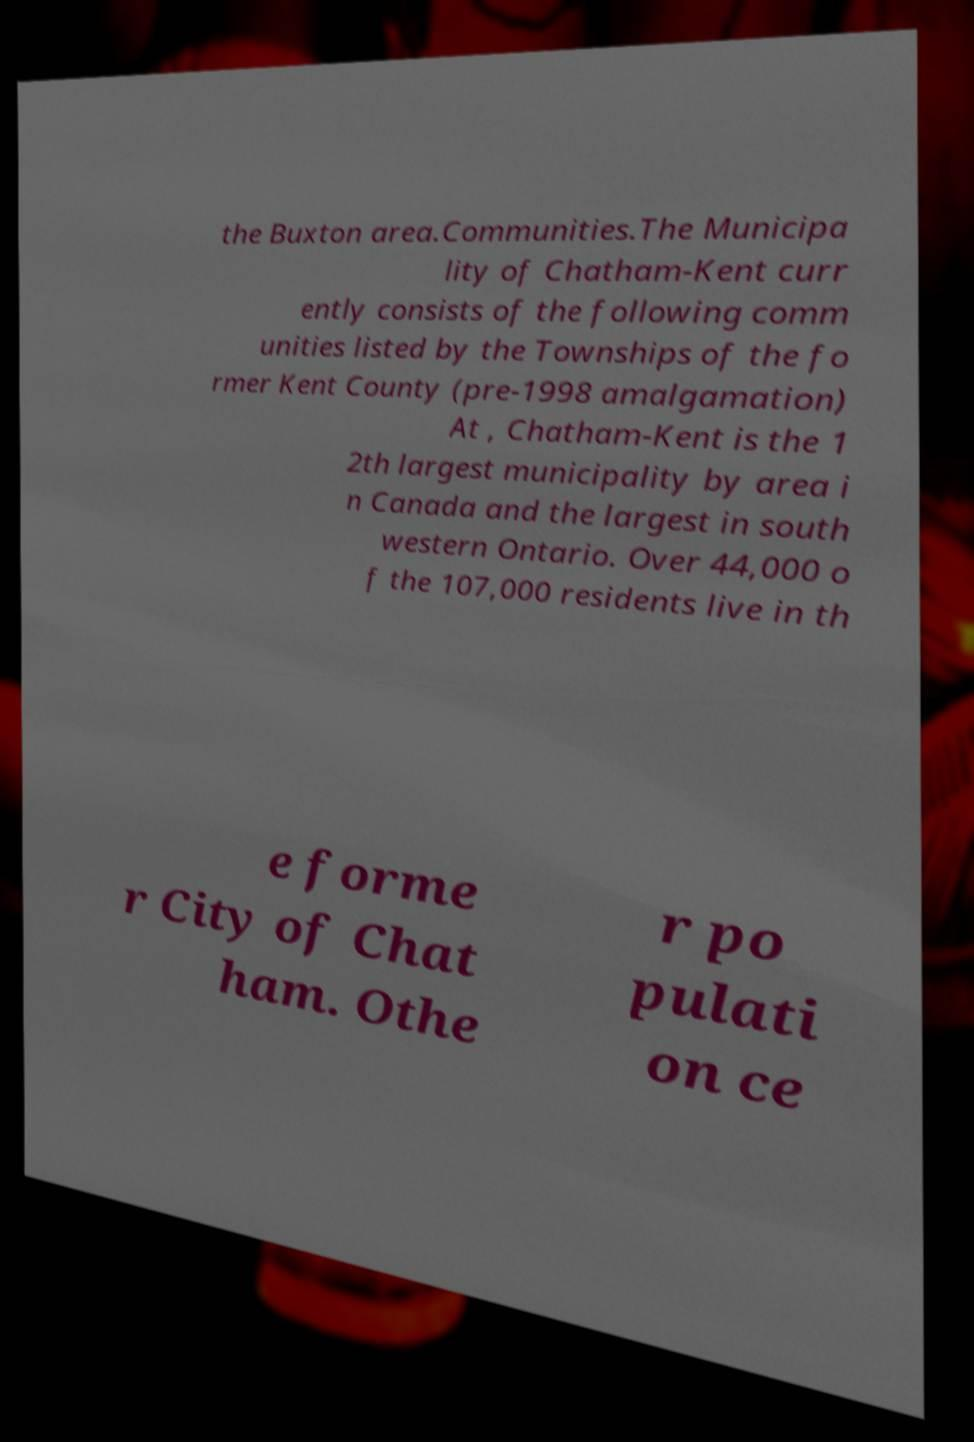Please identify and transcribe the text found in this image. the Buxton area.Communities.The Municipa lity of Chatham-Kent curr ently consists of the following comm unities listed by the Townships of the fo rmer Kent County (pre-1998 amalgamation) At , Chatham-Kent is the 1 2th largest municipality by area i n Canada and the largest in south western Ontario. Over 44,000 o f the 107,000 residents live in th e forme r City of Chat ham. Othe r po pulati on ce 